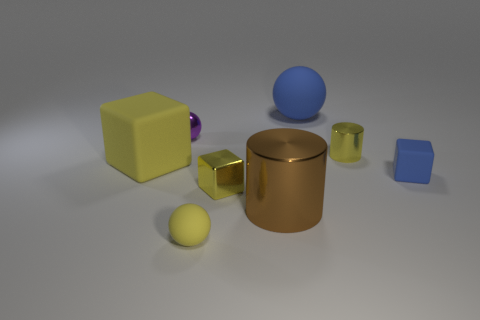Are there fewer tiny shiny cylinders that are behind the big yellow cube than large red metal cylinders?
Keep it short and to the point. No. Is there a blue ball of the same size as the brown metal thing?
Provide a short and direct response. Yes. There is a big block that is the same material as the large sphere; what is its color?
Keep it short and to the point. Yellow. There is a big matte object that is to the left of the purple metallic sphere; how many tiny yellow balls are behind it?
Your answer should be very brief. 0. What is the material of the tiny yellow object that is both behind the brown object and in front of the big block?
Offer a very short reply. Metal. There is a large matte thing that is behind the small purple metal object; does it have the same shape as the brown metallic object?
Your response must be concise. No. Is the number of cylinders less than the number of big green matte blocks?
Your answer should be compact. No. How many cylinders have the same color as the large cube?
Make the answer very short. 1. There is a tiny object that is the same color as the large sphere; what is its material?
Your response must be concise. Rubber. There is a tiny metallic block; is its color the same as the matte cube on the left side of the big blue matte thing?
Your response must be concise. Yes. 